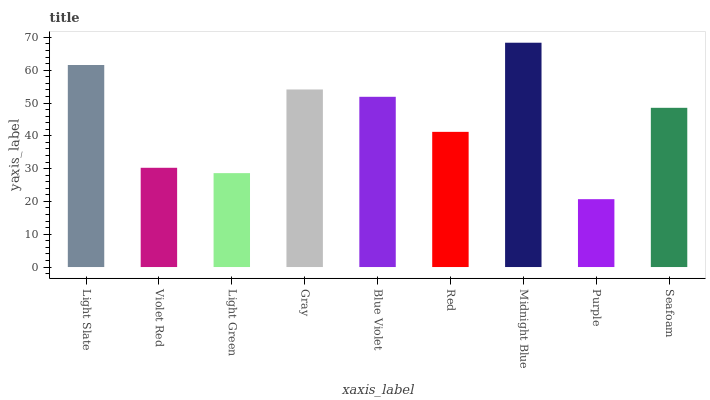Is Violet Red the minimum?
Answer yes or no. No. Is Violet Red the maximum?
Answer yes or no. No. Is Light Slate greater than Violet Red?
Answer yes or no. Yes. Is Violet Red less than Light Slate?
Answer yes or no. Yes. Is Violet Red greater than Light Slate?
Answer yes or no. No. Is Light Slate less than Violet Red?
Answer yes or no. No. Is Seafoam the high median?
Answer yes or no. Yes. Is Seafoam the low median?
Answer yes or no. Yes. Is Midnight Blue the high median?
Answer yes or no. No. Is Light Slate the low median?
Answer yes or no. No. 